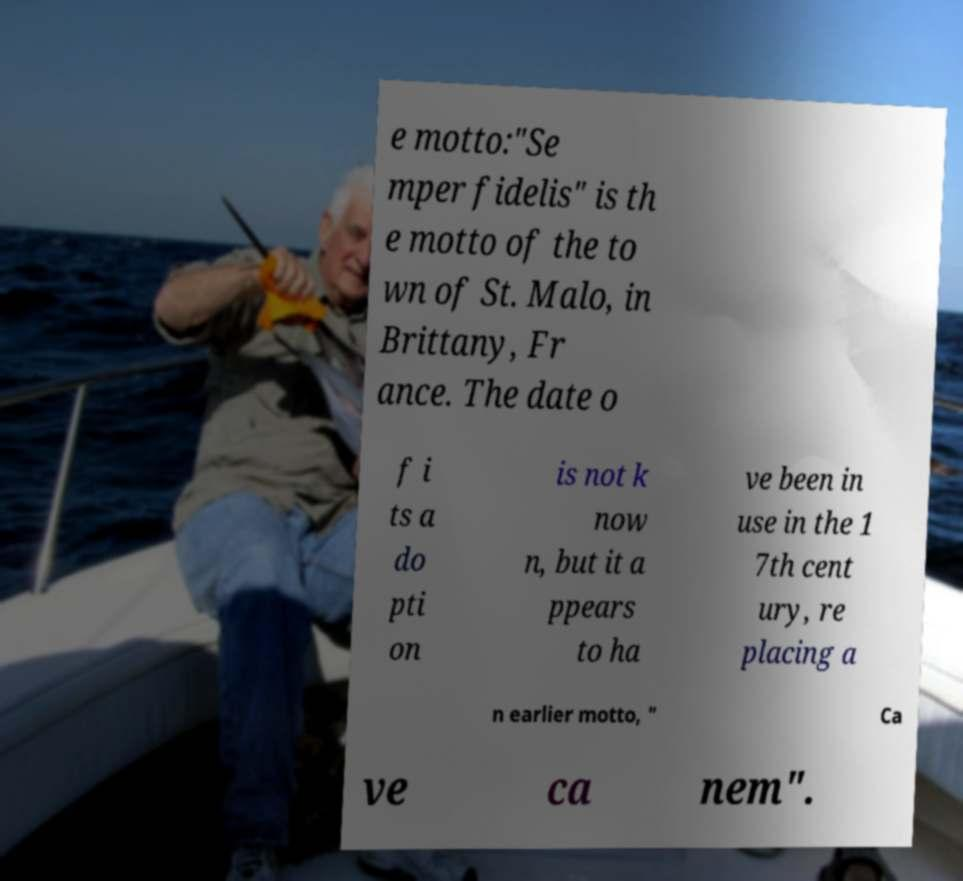Please read and relay the text visible in this image. What does it say? e motto:"Se mper fidelis" is th e motto of the to wn of St. Malo, in Brittany, Fr ance. The date o f i ts a do pti on is not k now n, but it a ppears to ha ve been in use in the 1 7th cent ury, re placing a n earlier motto, " Ca ve ca nem". 